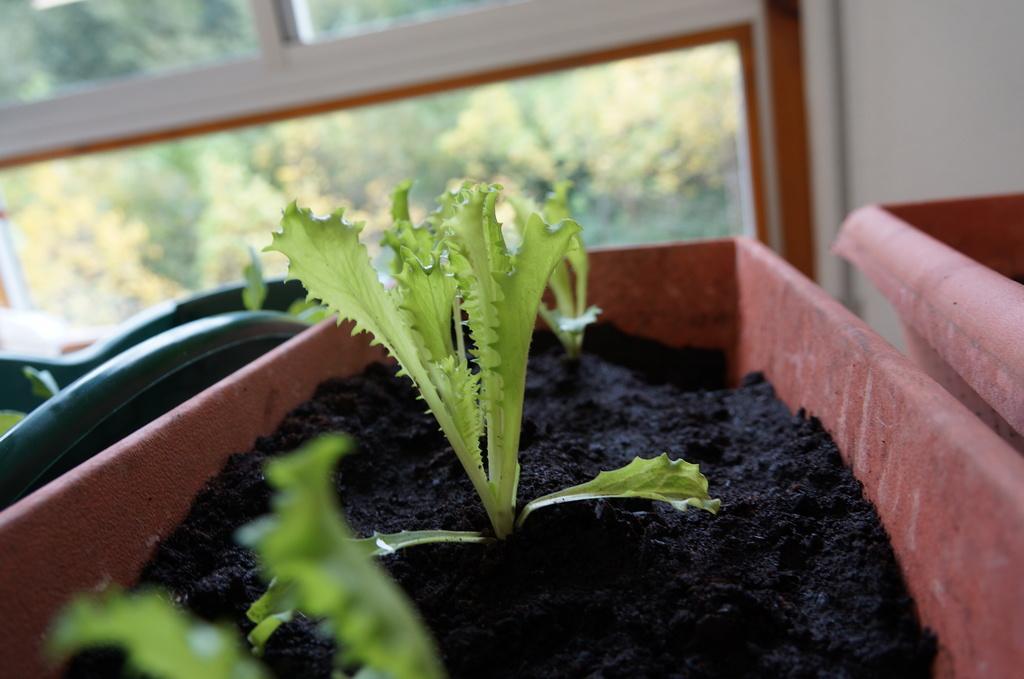Describe this image in one or two sentences. In this picture we can see some plants are kept in a pot, back side, we can see the window to the wall. 